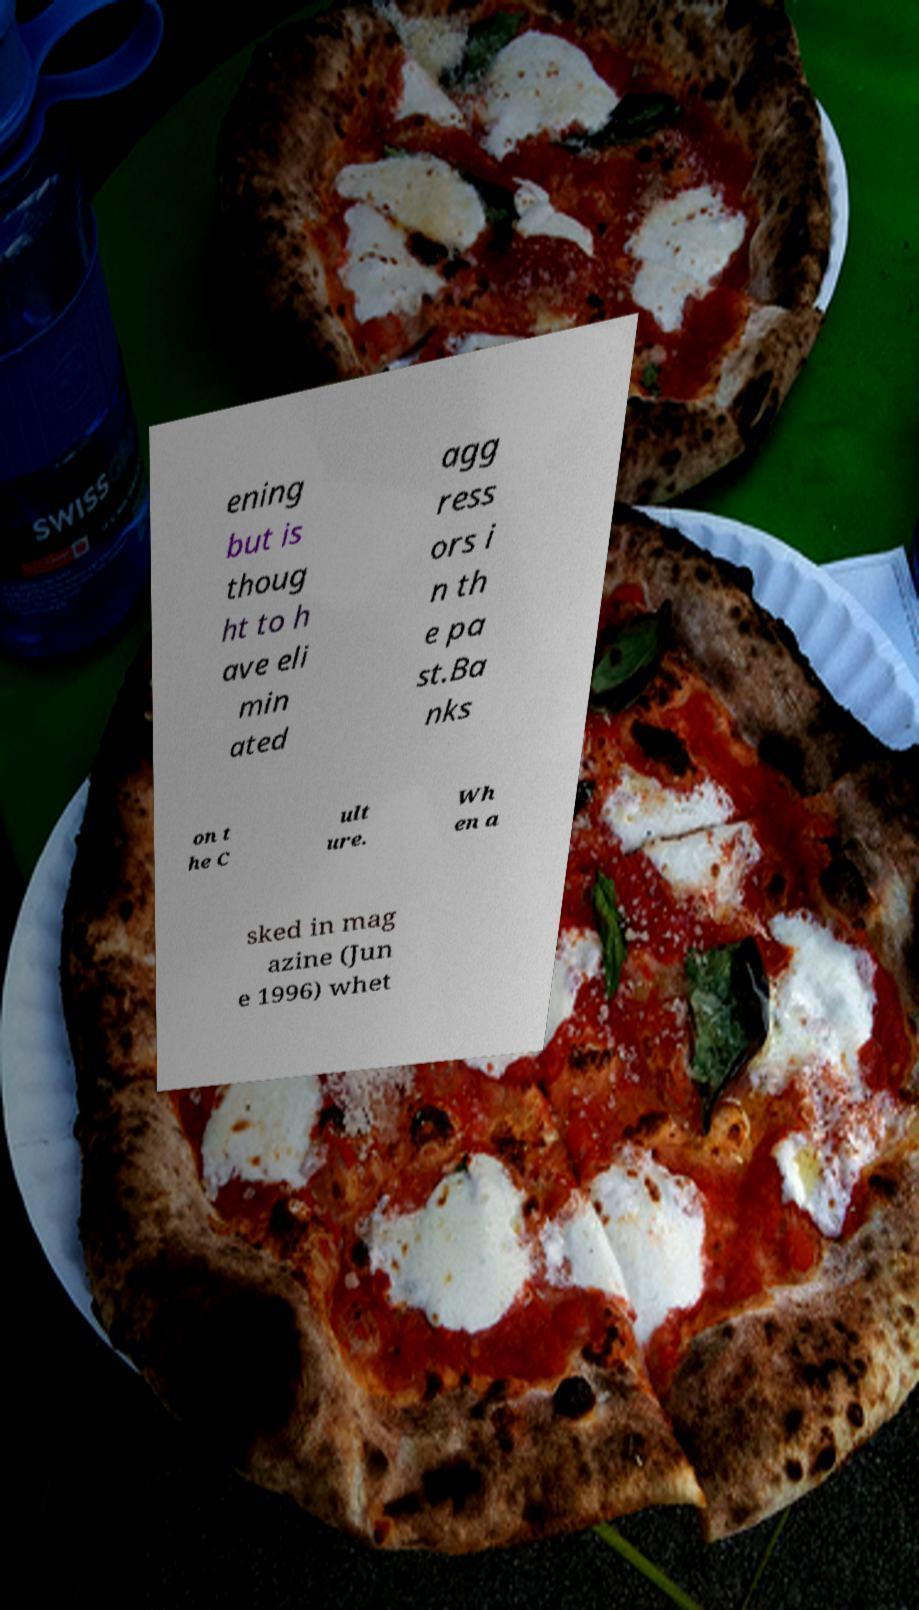Could you assist in decoding the text presented in this image and type it out clearly? ening but is thoug ht to h ave eli min ated agg ress ors i n th e pa st.Ba nks on t he C ult ure. Wh en a sked in mag azine (Jun e 1996) whet 